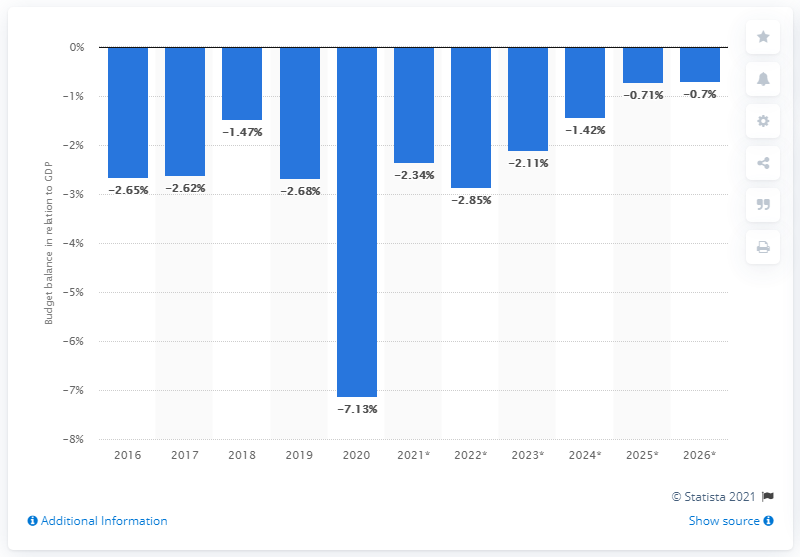Outline some significant characteristics in this image. Chile's budget balance, in relation to its GDP, is shown between the years 2016 and 2020. 